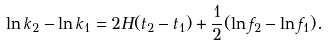Convert formula to latex. <formula><loc_0><loc_0><loc_500><loc_500>\ln { k } _ { 2 } - \ln { k } _ { 1 } = 2 H ( t _ { 2 } - t _ { 1 } ) + \frac { 1 } { 2 } ( \ln { f _ { 2 } } - \ln { f _ { 1 } } ) .</formula> 